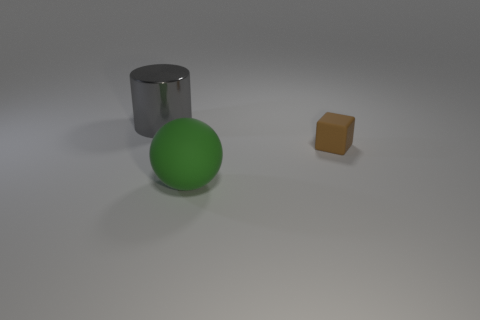Add 3 large gray metal cylinders. How many objects exist? 6 Subtract all cylinders. How many objects are left? 2 Add 3 matte objects. How many matte objects are left? 5 Add 3 big shiny cylinders. How many big shiny cylinders exist? 4 Subtract 0 red cylinders. How many objects are left? 3 Subtract all blocks. Subtract all spheres. How many objects are left? 1 